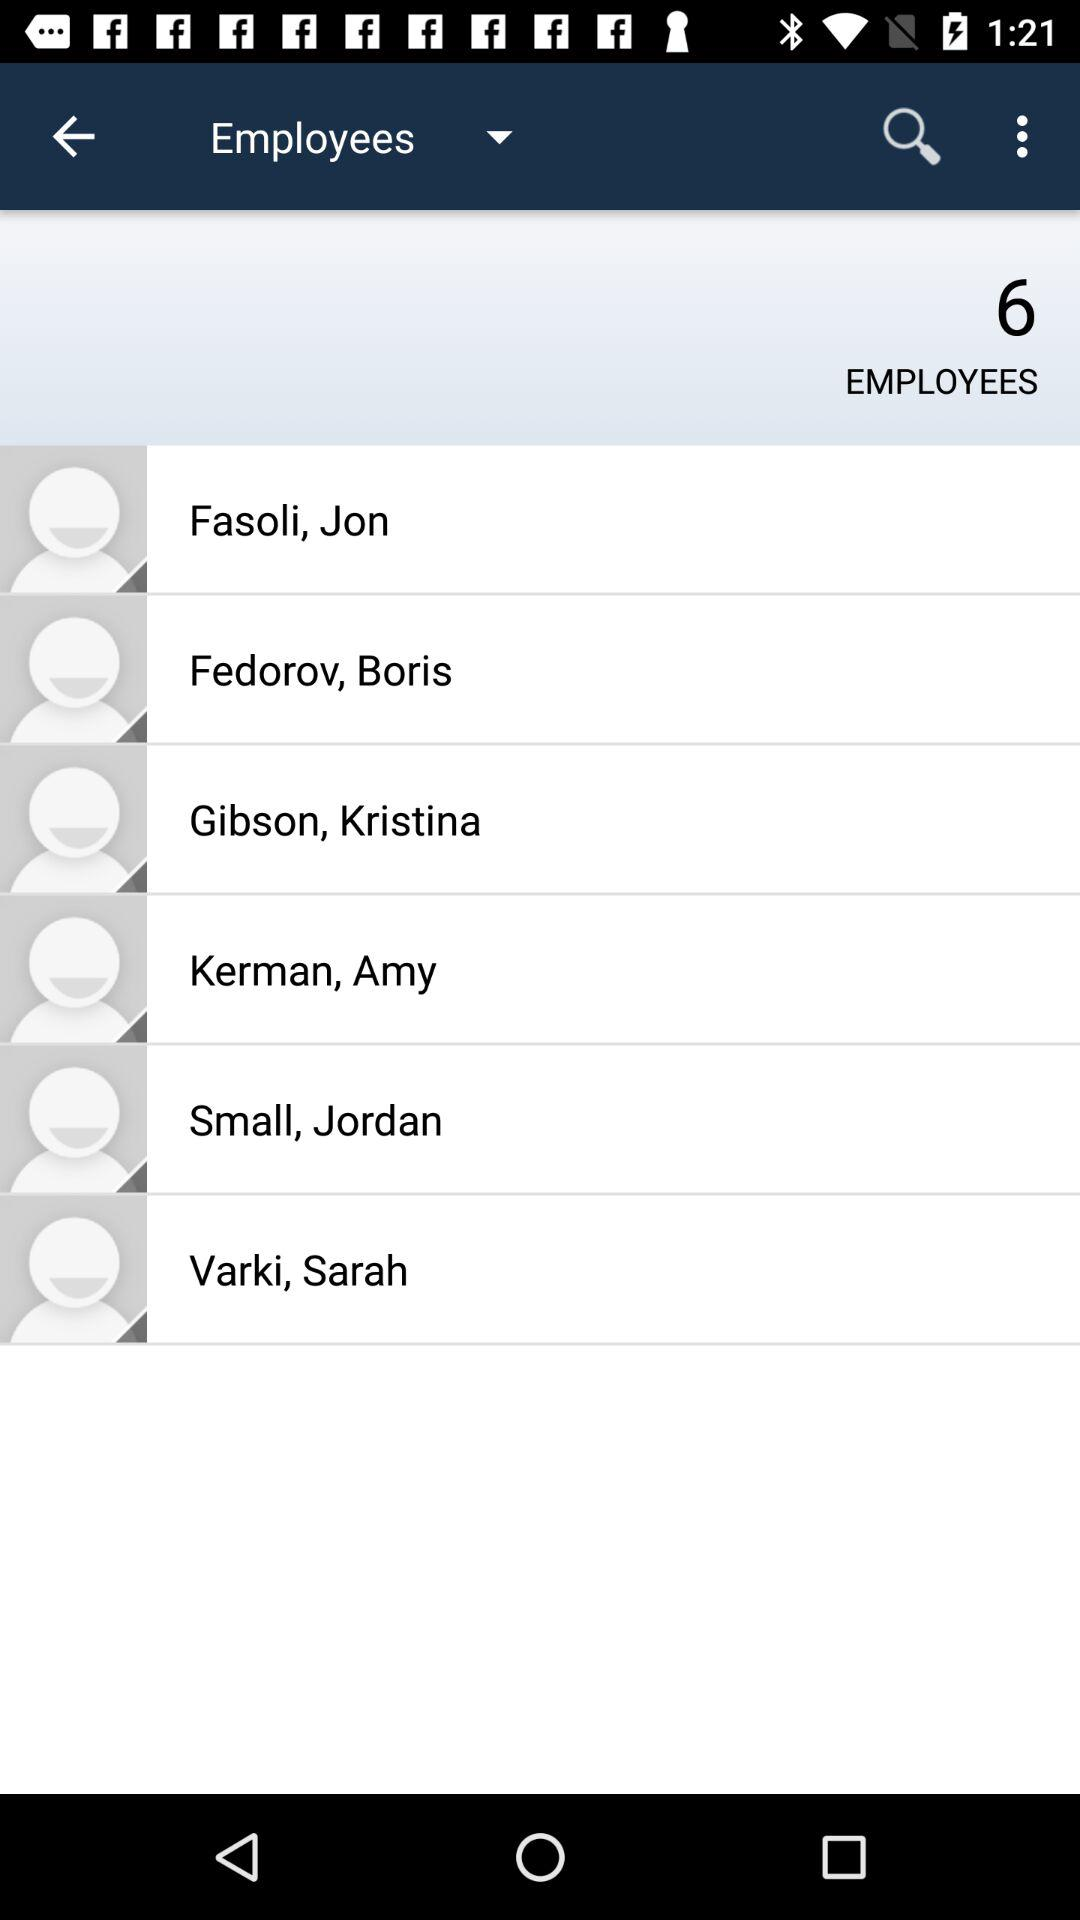What are the names of the employees? The names of the employees are Jon Fasoli, Boris Fedorov, Kristina Gibson, Amy Kerman, Jordan Small and Sarah Varki. 